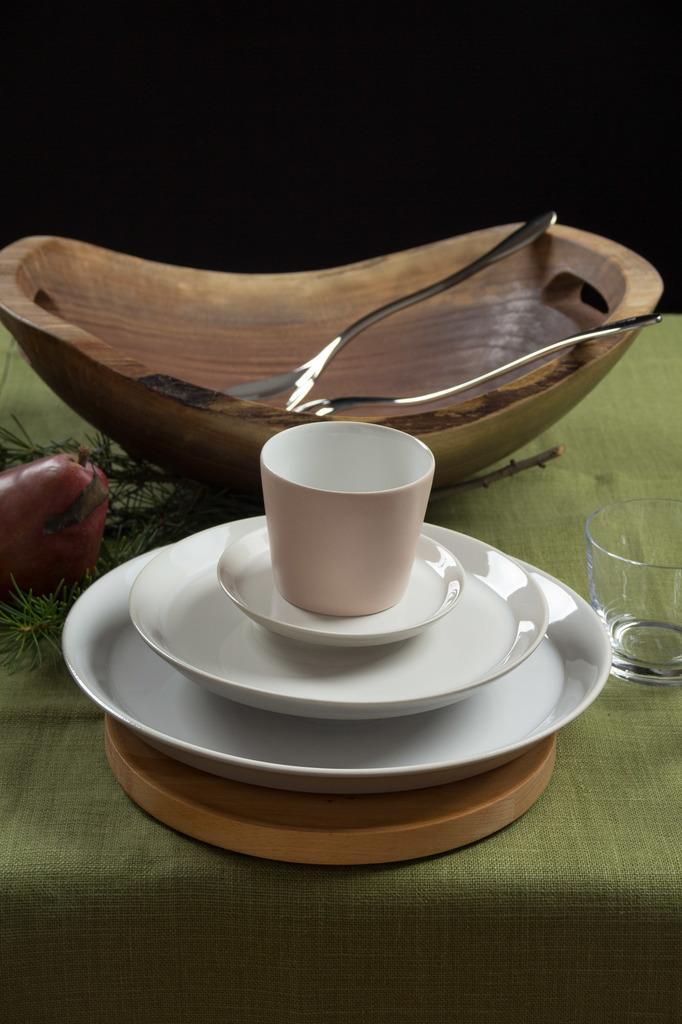Could you give a brief overview of what you see in this image? In the image on the green cloth there is a wooden plate. On the plate there are three plates with a cup. Behind the plates there is a wooden bowl with spoons. On the right side of the image there is a glass. And on the left side of the image there are leaves and also there is a fruit. 